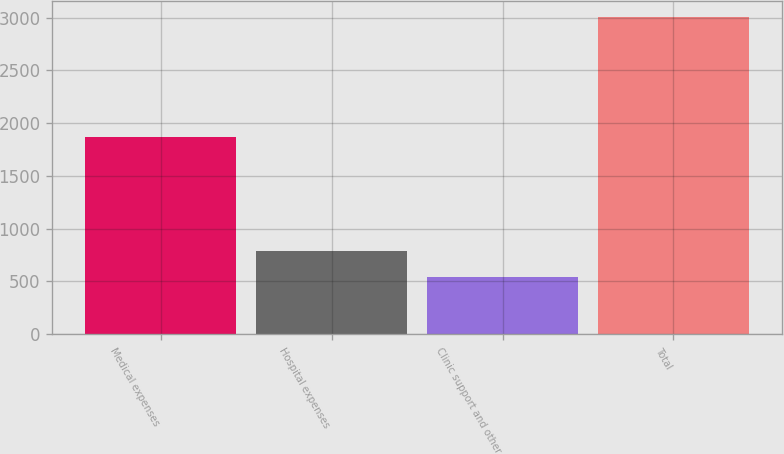Convert chart. <chart><loc_0><loc_0><loc_500><loc_500><bar_chart><fcel>Medical expenses<fcel>Hospital expenses<fcel>Clinic support and other<fcel>Total<nl><fcel>1865<fcel>785.7<fcel>539<fcel>3006<nl></chart> 